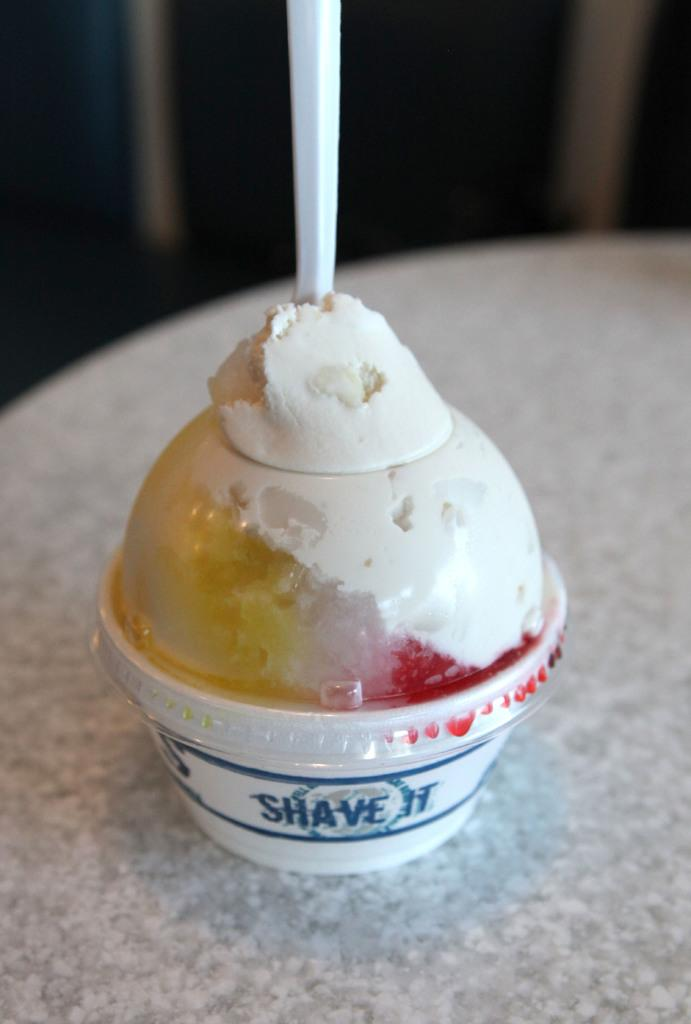What type of dessert is present in the image? There is ice cream in the image. Where is the ice cream located? The ice cream is in the cup. What colors can be seen in the ice cream? The ice cream has white, yellow, and red colors. What is the color of the surface the cup is placed on? The cup is on a white surface. How many men are acting in the shade in the image? There are no men or actors present in the image, and there is no shade mentioned. 